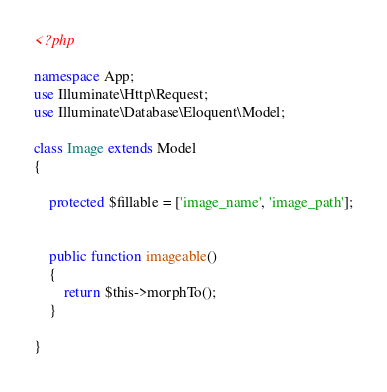<code> <loc_0><loc_0><loc_500><loc_500><_PHP_><?php

namespace App;
use Illuminate\Http\Request;
use Illuminate\Database\Eloquent\Model;

class Image extends Model
{

    protected $fillable = ['image_name', 'image_path'];


    public function imageable()
    {
        return $this->morphTo();
    }

}
</code> 